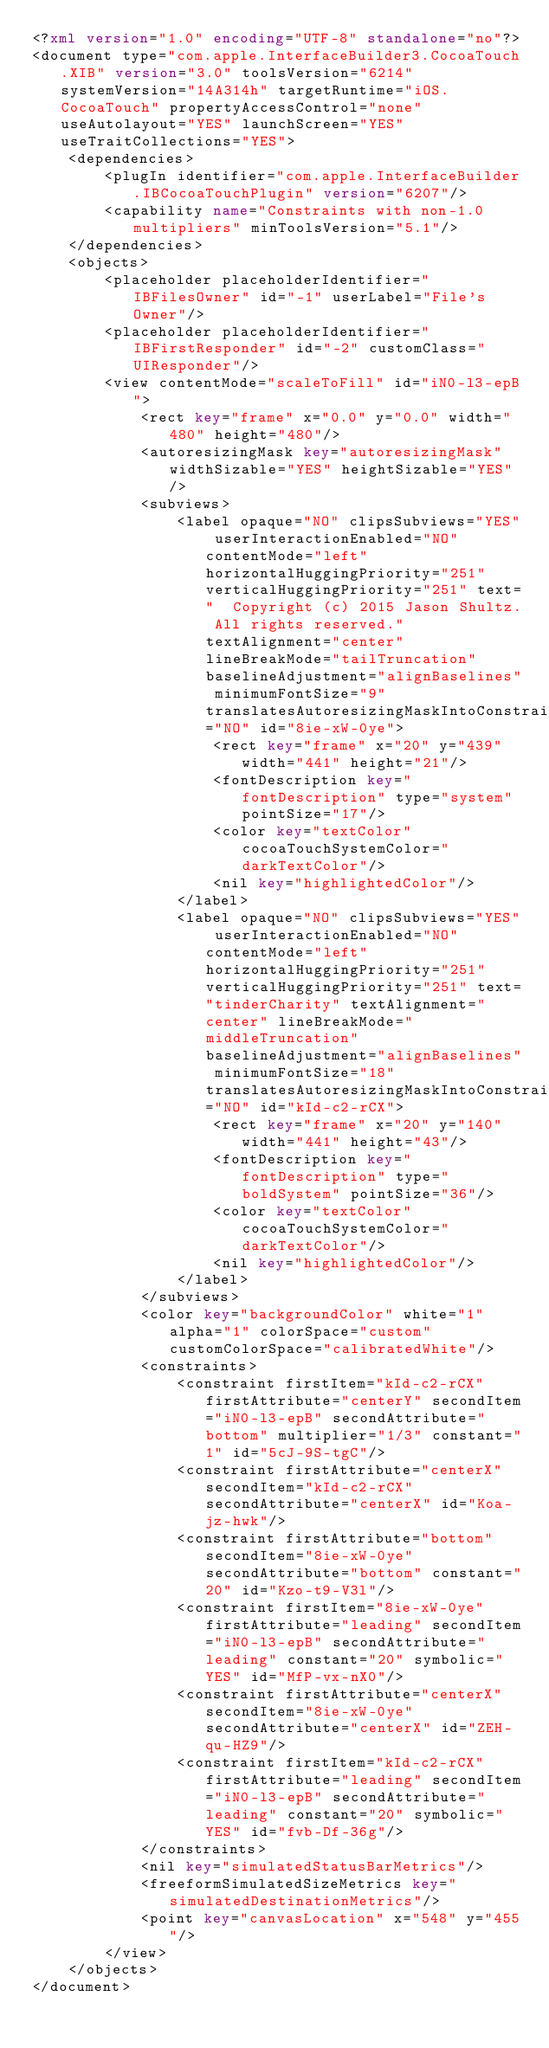<code> <loc_0><loc_0><loc_500><loc_500><_XML_><?xml version="1.0" encoding="UTF-8" standalone="no"?>
<document type="com.apple.InterfaceBuilder3.CocoaTouch.XIB" version="3.0" toolsVersion="6214" systemVersion="14A314h" targetRuntime="iOS.CocoaTouch" propertyAccessControl="none" useAutolayout="YES" launchScreen="YES" useTraitCollections="YES">
    <dependencies>
        <plugIn identifier="com.apple.InterfaceBuilder.IBCocoaTouchPlugin" version="6207"/>
        <capability name="Constraints with non-1.0 multipliers" minToolsVersion="5.1"/>
    </dependencies>
    <objects>
        <placeholder placeholderIdentifier="IBFilesOwner" id="-1" userLabel="File's Owner"/>
        <placeholder placeholderIdentifier="IBFirstResponder" id="-2" customClass="UIResponder"/>
        <view contentMode="scaleToFill" id="iN0-l3-epB">
            <rect key="frame" x="0.0" y="0.0" width="480" height="480"/>
            <autoresizingMask key="autoresizingMask" widthSizable="YES" heightSizable="YES"/>
            <subviews>
                <label opaque="NO" clipsSubviews="YES" userInteractionEnabled="NO" contentMode="left" horizontalHuggingPriority="251" verticalHuggingPriority="251" text="  Copyright (c) 2015 Jason Shultz. All rights reserved." textAlignment="center" lineBreakMode="tailTruncation" baselineAdjustment="alignBaselines" minimumFontSize="9" translatesAutoresizingMaskIntoConstraints="NO" id="8ie-xW-0ye">
                    <rect key="frame" x="20" y="439" width="441" height="21"/>
                    <fontDescription key="fontDescription" type="system" pointSize="17"/>
                    <color key="textColor" cocoaTouchSystemColor="darkTextColor"/>
                    <nil key="highlightedColor"/>
                </label>
                <label opaque="NO" clipsSubviews="YES" userInteractionEnabled="NO" contentMode="left" horizontalHuggingPriority="251" verticalHuggingPriority="251" text="tinderCharity" textAlignment="center" lineBreakMode="middleTruncation" baselineAdjustment="alignBaselines" minimumFontSize="18" translatesAutoresizingMaskIntoConstraints="NO" id="kId-c2-rCX">
                    <rect key="frame" x="20" y="140" width="441" height="43"/>
                    <fontDescription key="fontDescription" type="boldSystem" pointSize="36"/>
                    <color key="textColor" cocoaTouchSystemColor="darkTextColor"/>
                    <nil key="highlightedColor"/>
                </label>
            </subviews>
            <color key="backgroundColor" white="1" alpha="1" colorSpace="custom" customColorSpace="calibratedWhite"/>
            <constraints>
                <constraint firstItem="kId-c2-rCX" firstAttribute="centerY" secondItem="iN0-l3-epB" secondAttribute="bottom" multiplier="1/3" constant="1" id="5cJ-9S-tgC"/>
                <constraint firstAttribute="centerX" secondItem="kId-c2-rCX" secondAttribute="centerX" id="Koa-jz-hwk"/>
                <constraint firstAttribute="bottom" secondItem="8ie-xW-0ye" secondAttribute="bottom" constant="20" id="Kzo-t9-V3l"/>
                <constraint firstItem="8ie-xW-0ye" firstAttribute="leading" secondItem="iN0-l3-epB" secondAttribute="leading" constant="20" symbolic="YES" id="MfP-vx-nX0"/>
                <constraint firstAttribute="centerX" secondItem="8ie-xW-0ye" secondAttribute="centerX" id="ZEH-qu-HZ9"/>
                <constraint firstItem="kId-c2-rCX" firstAttribute="leading" secondItem="iN0-l3-epB" secondAttribute="leading" constant="20" symbolic="YES" id="fvb-Df-36g"/>
            </constraints>
            <nil key="simulatedStatusBarMetrics"/>
            <freeformSimulatedSizeMetrics key="simulatedDestinationMetrics"/>
            <point key="canvasLocation" x="548" y="455"/>
        </view>
    </objects>
</document>
</code> 